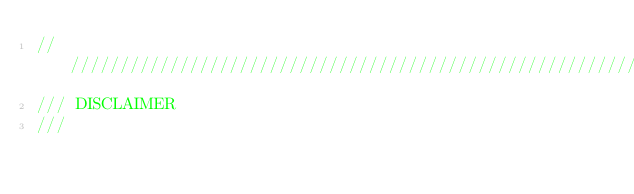<code> <loc_0><loc_0><loc_500><loc_500><_C_>////////////////////////////////////////////////////////////////////////////////
/// DISCLAIMER
///</code> 